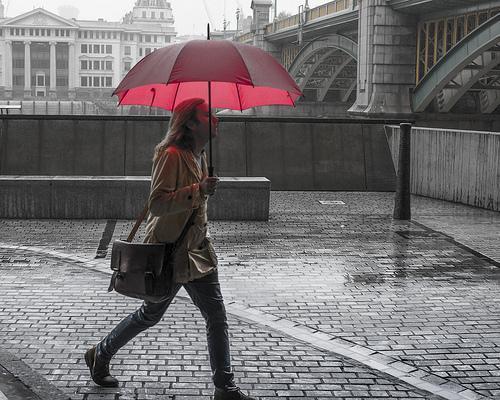How many orangutans are riding on the umbrella?
Give a very brief answer. 0. 